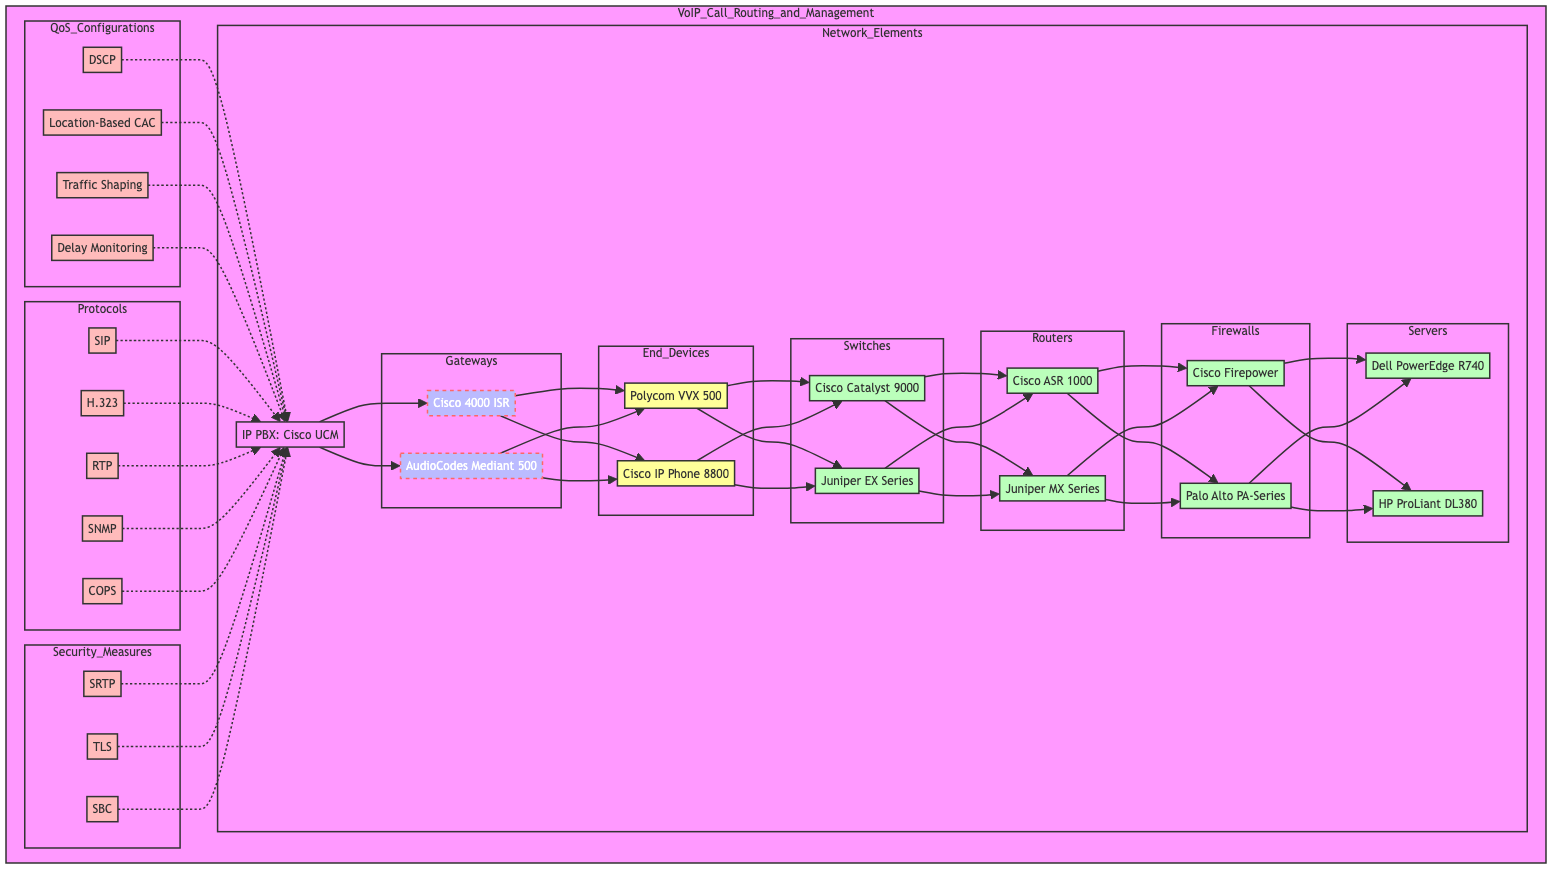What is the IP PBX used in this network diagram? The diagram specifies the IP PBX as "Cisco Unified Communications Manager" under the "Network_Elements" section.
Answer: Cisco Unified Communications Manager How many gateways are present in this VoIP network? The diagram lists two gateways: "Cisco 4000 Series Integrated Services Routers" and "AudioCodes Mediant 500 Gateway." Therefore, the total count is two.
Answer: 2 Which end device does Cisco offer in this setup? Among the end devices, "Cisco IP Phone 8800 Series" is identified as a Cisco product.
Answer: Cisco IP Phone 8800 Series What request does the session border controller serve? The session border controller, represented in the "Security_Measures" section, aids in "Firewall Traversal."
Answer: Firewall Traversal What QoS configuration type is used for traffic prioritization? The diagram mentions "Differentiated Services Code Point (DSCP)" as the method for traffic prioritization under QoS configurations.
Answer: Differentiated Services Code Point (DSCP) Which signaling protocol is included in the diagram? The diagram includes "Session Initiation Protocol (SIP)" under the "Signaling_Protocols" section as one of the signaling protocols utilized.
Answer: Session Initiation Protocol (SIP) How do end devices connect to the network? In the diagram, end devices connect to the network through the gateways ("Cisco 4000 ISR" and "AudioCodes Mediant 500"), which route to them.
Answer: Through gateways What is the relationship between the IP PBX and QoS configurations? The line connecting the IP PBX indicates that QoS configurations, including traffic prioritization, call admission control, bandwidth management, and latency management, are reliant on or affect the IP PBX operations.
Answer: Affect IP PBX operations What type of servers are represented in this network? The servers depicted in the network are "Dell PowerEdge R740 Rack Server" and "HP ProLiant DL380 Gen10," both of which are classified as rack servers.
Answer: Rack servers 